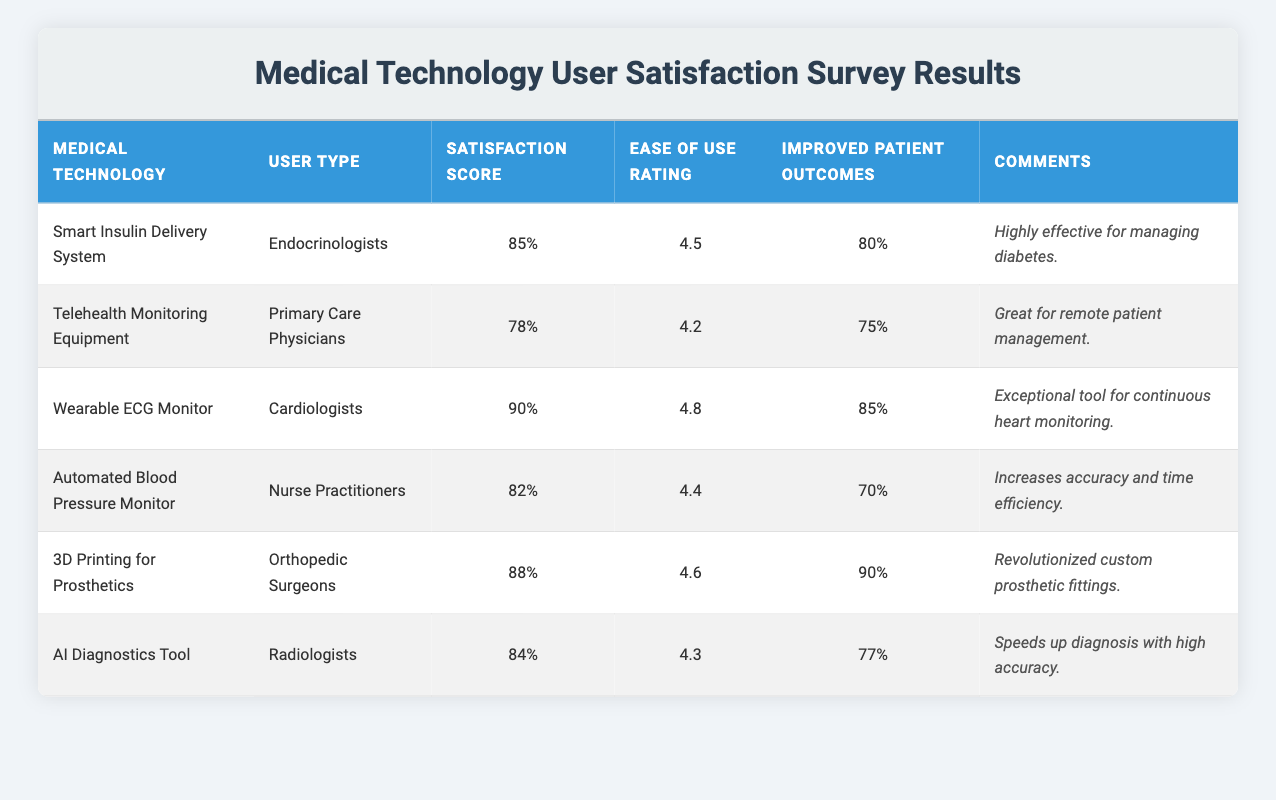What's the satisfaction score for the Wearable ECG Monitor? The table shows that the satisfaction score for the Wearable ECG Monitor is listed specifically in the "Satisfaction Score" column for that row. By locating the row corresponding to the Wearable ECG Monitor, we see that it has a satisfaction score of 90%.
Answer: 90% Which medical technology had the highest ease of use rating? Looking at the "Ease of Use Rating" column, we compare the ratings for each medical technology. The Wearable ECG Monitor has the highest rating of 4.8.
Answer: Wearable ECG Monitor What percentage of improved patient outcomes is associated with the 3D Printing for Prosthetics? The table indicates that the "Improved Patient Outcomes" column contains specific percentages for each medical technology. For the 3D Printing for Prosthetics, this value is 90%.
Answer: 90% Is the satisfaction score for the Telehealth Monitoring Equipment higher than 80? To answer this, we look at the "Satisfaction Score" for the Telehealth Monitoring Equipment, which is 78%. Since 78% is less than 80%, the answer is no.
Answer: No What is the average satisfaction score for all medical technologies listed? To find the average, we first sum the satisfaction scores: 85 + 78 + 90 + 82 + 88 + 84 = 507. Then, we divide by the number of technologies, which is 6, thus 507 / 6 = 84.5.
Answer: 84.5 What is the difference between the highest and lowest ease of use rating among these technologies? The highest ease of use rating is 4.8 (Wearable ECG Monitor) and the lowest is 4.2 (Telehealth Monitoring Equipment). The difference is calculated as 4.8 - 4.2 = 0.6.
Answer: 0.6 Do Nurse Practitioners have a satisfaction score that is equal to or greater than 80? Looking at the satisfaction score for Nurse Practitioners, we find it to be 82%. Since 82% is greater than 80%, the answer is yes.
Answer: Yes Which user type reported the highest percentage of improved patient outcomes? By examining the "Improved Patient Outcomes" column, we find that Orthopedic Surgeons reported 90% for 3D Printing for Prosthetics, which is the highest among all user types.
Answer: Orthopedic Surgeons What comment did the Radiologists leave regarding the AI Diagnostics Tool? The table contains a "Comments" column where each technology's user type has left their feedback. For the AI Diagnostics Tool, Radiologists commented: "Speeds up diagnosis with high accuracy."
Answer: Speeds up diagnosis with high accuracy 